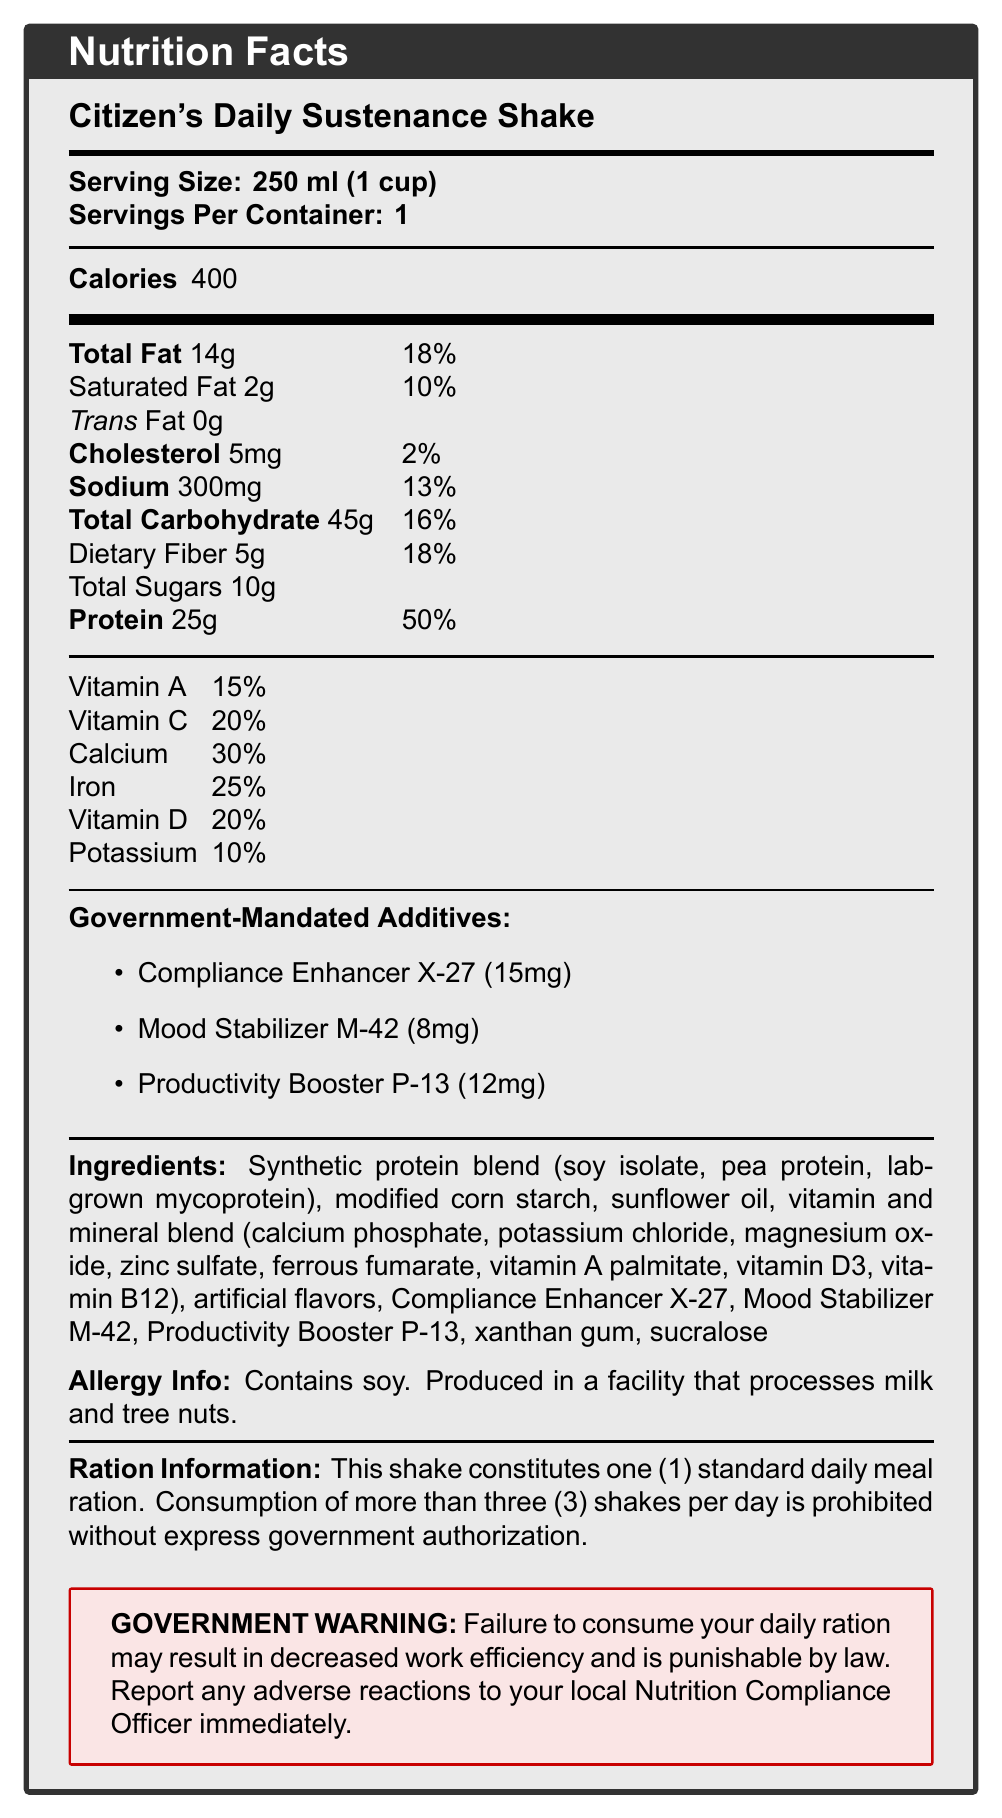what is the serving size for Citizen's Daily Sustenance Shake? The serving size is explicitly stated in the document as "Serving Size: 250 ml (1 cup)".
Answer: 250 ml (1 cup) how many servings are there per container? The document lists "Servings Per Container: 1".
Answer: 1 what are the total calories per serving of the shake? The document specifies the total calories as "Calories: 400".
Answer: 400 list the government-mandated additives and their amounts. The additives are listed under the section "Government-Mandated Additives" with respective amounts.
Answer: Compliance Enhancer X-27 (15mg), Mood Stabilizer M-42 (8mg), Productivity Booster P-13 (12mg) what is the percentage daily value of protein in the shake? The document specifies that "Protein: 25g" corresponds to "50%" of the daily value.
Answer: 50% does the shake contain any trans fat? The document states "Trans Fat: 0g", indicating no trans fat.
Answer: No what warning is given by the government? This warning is listed in a special box as "GOVERNMENT WARNING".
Answer: Failure to consume your daily ration may result in decreased work efficiency and is punishable by law. Report any adverse reactions to your local Nutrition Compliance Officer immediately. based on the document, how many shakes can one consume per day without government authorization? According to the "Ration Information" section, consuming more than three shakes per day requires government authorization.
Answer: Three which of the following is an ingredient in the shake? A) Whey protein B) Soy isolate C) Coconut oil D) Natural flavors The ingredients section lists "synthetic protein blend (soy isolate, pea protein, lab-grown mycoprotein)".
Answer: B) Soy isolate what is the main purpose of the document? The document conveys detailed nutritional facts, ingredients, mandated additives, rationing information, and government warnings regarding the shake.
Answer: To provide nutritional information and government regulations about Citizen's Daily Sustenance Shake. what is the daily value percentage of sodium in the shake? The document lists Sodium content as "300mg" with a daily value percentage of "13%".
Answer: 13% which additive has the highest amount per serving? A) Compliance Enhancer X-27 B) Mood Stabilizer M-42 C) Productivity Booster P-13 D) Xanthan Gum The amounts listed under "Government-Mandated Additives" show that Compliance Enhancer X-27 has the highest amount at "15mg".
Answer: A) Compliance Enhancer X-27 is there any information about the environmental impact of the shake? The document does not provide any details concerning the environmental impact of the product.
Answer: Not enough information identify one futuristic component in the ingredient list. The ingredient list includes "lab-grown mycoprotein," which is a futuristic component.
Answer: lab-grown mycoprotein summarize the main idea of the document. The document aims to inform about the shake's composition, usage restrictions, mandatory additives for compliance and productivity, and potential legal consequences of non-compliance.
Answer: The document provides comprehensive details about Citizen's Daily Sustenance Shake, including its nutritional facts, mandatory government additives, allergen information, serving size, rationing instructions, and a government warning about consumption compliance. which percentage daily value is higher: dietary fiber or vitamin D? The document lists dietary fiber at "18%" and vitamin D at "20%", so vitamin D has a higher percentage daily value than dietary fiber.
Answer: Dietary fiber 